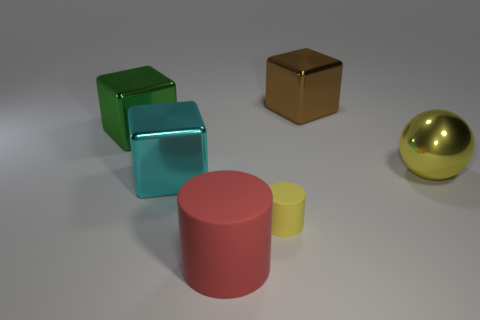There is a object that is behind the large green metallic object; is it the same shape as the large yellow object to the right of the large rubber object?
Ensure brevity in your answer.  No. How many yellow shiny spheres are on the left side of the big brown metallic object?
Your answer should be very brief. 0. Is there a big block that has the same material as the green object?
Offer a very short reply. Yes. There is a red object that is the same size as the yellow ball; what is its material?
Give a very brief answer. Rubber. Is the red object made of the same material as the big green cube?
Offer a terse response. No. What number of objects are large blue cubes or yellow metallic things?
Give a very brief answer. 1. What is the shape of the rubber thing in front of the tiny yellow rubber cylinder?
Ensure brevity in your answer.  Cylinder. What is the color of the sphere that is made of the same material as the brown cube?
Offer a very short reply. Yellow. There is another object that is the same shape as the tiny yellow rubber object; what is it made of?
Your answer should be compact. Rubber. What shape is the green shiny thing?
Your response must be concise. Cube. 